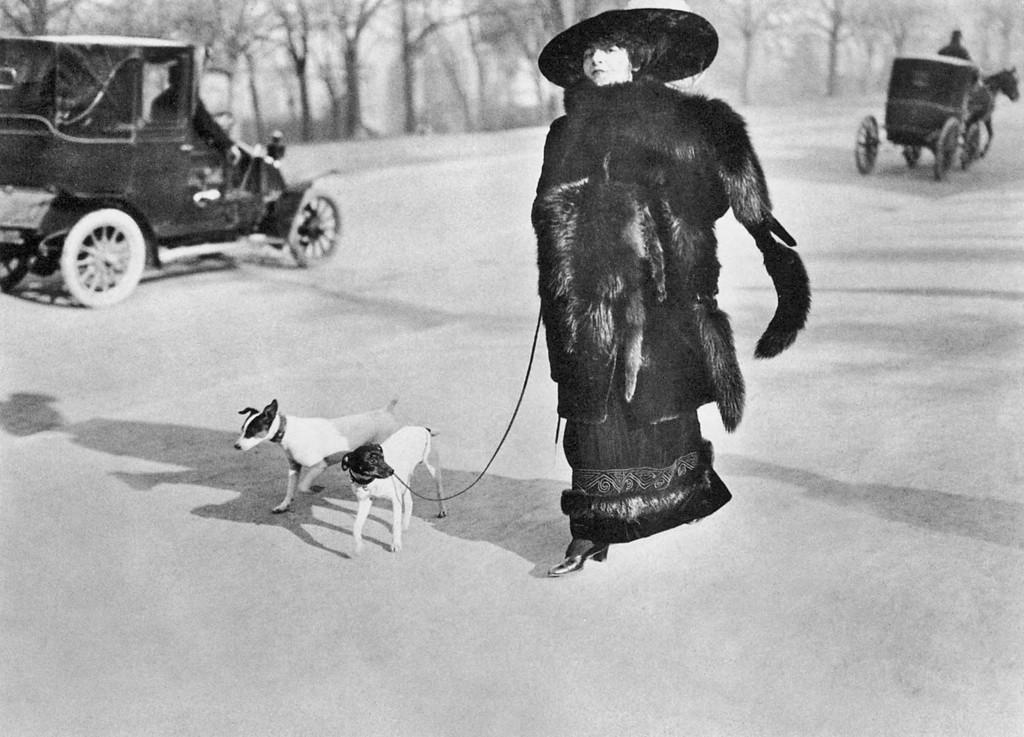Describe this image in one or two sentences. The person wearing black dress is holding a belt which is tightened to a dog and there is another dog beside it and there are two vehicles in the background. 